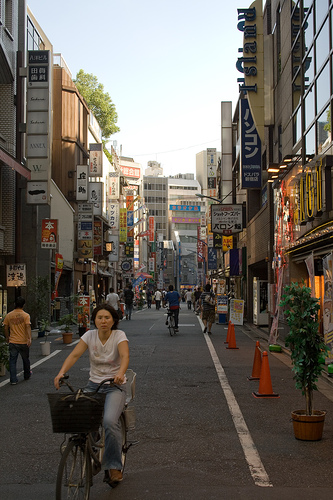<image>What traffic practice is she emphasizing? It is ambiguous what traffic practice she is emphasizing. It could be proper lane usage or proper biking technique like having both hands on handlebars. What traffic practice is she emphasizing? She is emphasizing proper lane traffic practice. 